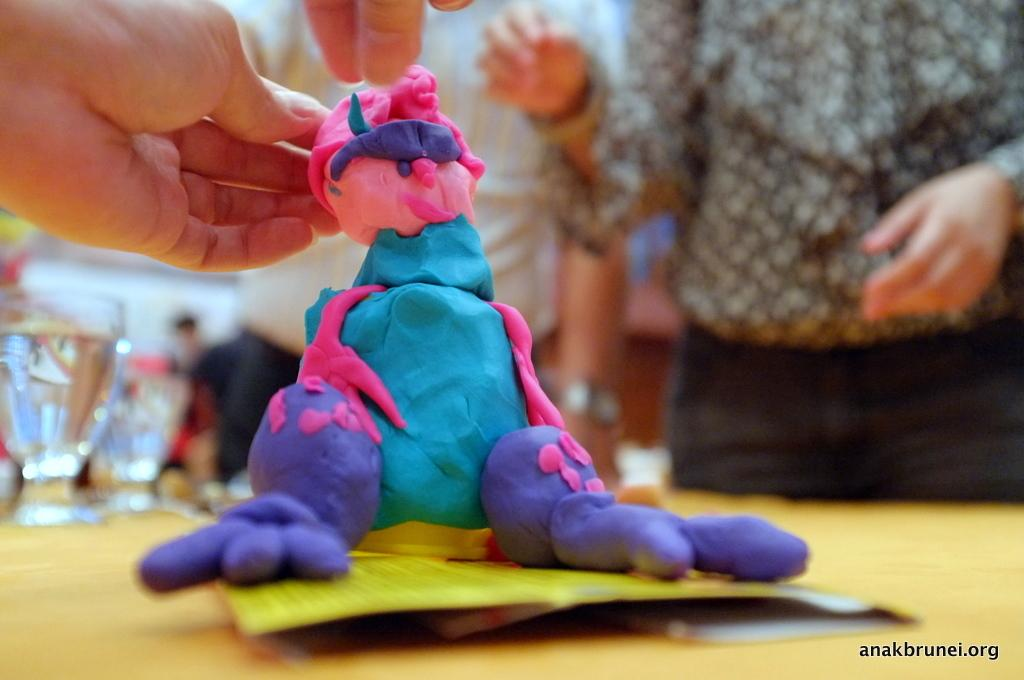How many people are in the image? There are persons in the image, but the exact number cannot be determined from the provided facts. What is present in the image besides the persons? There is a table in the image, as well as a toy and glasses on the table. How many elbows can be seen on the persons in the image? There is no information about the number of elbows visible in the image, as the focus is on the presence of persons, a table, a toy, and glasses. 